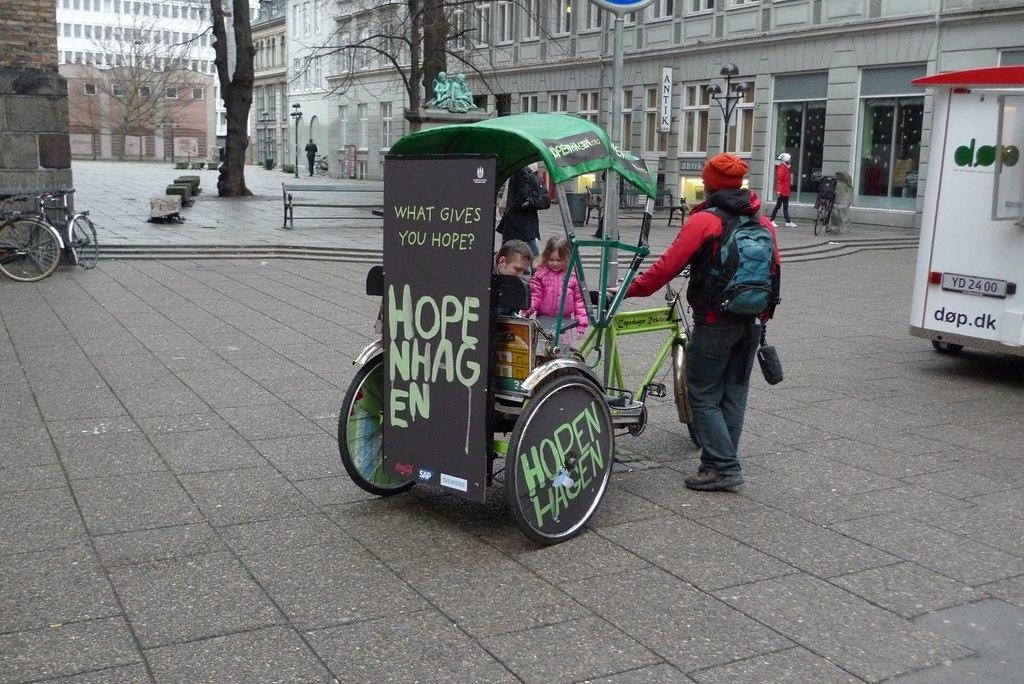How would you summarize this image in a sentence or two? In this image we can see cycle rickshaw. On that there is text. Also there are few people. One person is wearing bag and cap. On the left side there is a cycle. Also there are trees. And there are buildings. And there are few people and there are benches. And there is light pole. And we can see statues. 